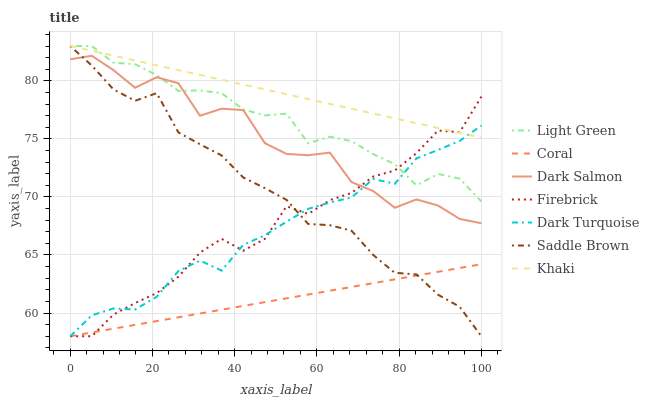Does Coral have the minimum area under the curve?
Answer yes or no. Yes. Does Khaki have the maximum area under the curve?
Answer yes or no. Yes. Does Dark Turquoise have the minimum area under the curve?
Answer yes or no. No. Does Dark Turquoise have the maximum area under the curve?
Answer yes or no. No. Is Coral the smoothest?
Answer yes or no. Yes. Is Dark Salmon the roughest?
Answer yes or no. Yes. Is Khaki the smoothest?
Answer yes or no. No. Is Khaki the roughest?
Answer yes or no. No. Does Coral have the lowest value?
Answer yes or no. Yes. Does Khaki have the lowest value?
Answer yes or no. No. Does Saddle Brown have the highest value?
Answer yes or no. Yes. Does Dark Turquoise have the highest value?
Answer yes or no. No. Is Coral less than Dark Salmon?
Answer yes or no. Yes. Is Light Green greater than Coral?
Answer yes or no. Yes. Does Dark Turquoise intersect Firebrick?
Answer yes or no. Yes. Is Dark Turquoise less than Firebrick?
Answer yes or no. No. Is Dark Turquoise greater than Firebrick?
Answer yes or no. No. Does Coral intersect Dark Salmon?
Answer yes or no. No. 